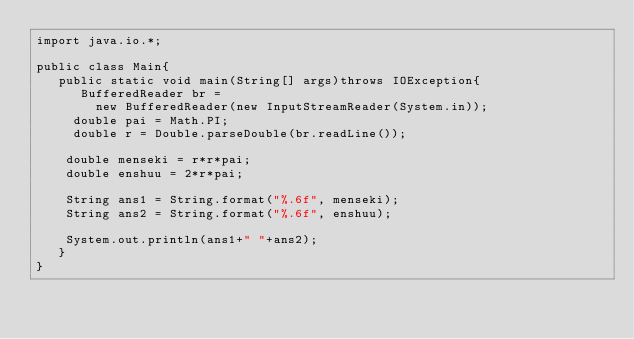Convert code to text. <code><loc_0><loc_0><loc_500><loc_500><_Java_>import java.io.*;

public class Main{
   public static void main(String[] args)throws IOException{
      BufferedReader br = 
        new BufferedReader(new InputStreamReader(System.in));
     double pai = Math.PI;
   	 double r = Double.parseDouble(br.readLine());
   	
   	double menseki = r*r*pai;
   	double enshuu = 2*r*pai;
   	
   	String ans1 = String.format("%.6f", menseki);
   	String ans2 = String.format("%.6f", enshuu);
   	
   	System.out.println(ans1+" "+ans2);
   }
}</code> 